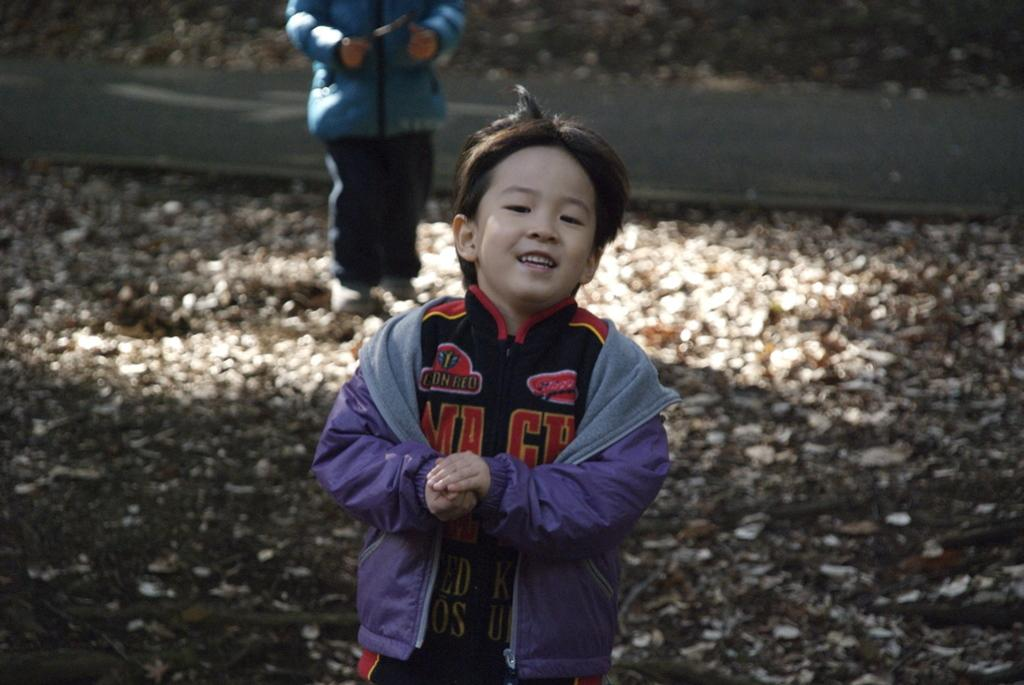How many children are present in the image? There are two children in the image. What are the children doing in the image? The children are on the ground. What can be seen in the background of the image? There is a road visible in the image. What type of glass is being used in the competition in the image? There is no competition or glass present in the image; it features two children on the ground with a road visible in the background. 